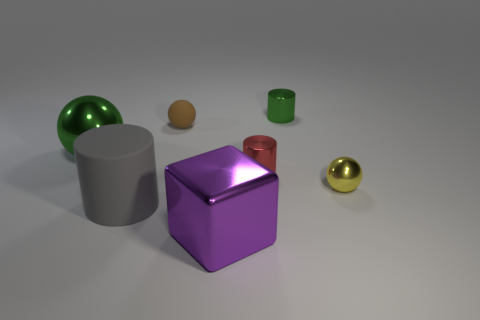Add 2 big brown metallic cylinders. How many objects exist? 9 Subtract all small shiny balls. How many balls are left? 2 Add 6 big red matte balls. How many big red matte balls exist? 6 Subtract 0 brown blocks. How many objects are left? 7 Subtract all blocks. How many objects are left? 6 Subtract 1 balls. How many balls are left? 2 Subtract all gray spheres. Subtract all red cubes. How many spheres are left? 3 Subtract all brown balls. How many purple cylinders are left? 0 Subtract all small purple things. Subtract all small brown matte spheres. How many objects are left? 6 Add 1 brown matte things. How many brown matte things are left? 2 